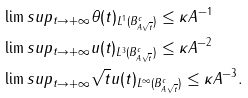<formula> <loc_0><loc_0><loc_500><loc_500>& \lim s u p _ { t \to + \infty } \| \theta ( t ) \| _ { L ^ { 1 } ( B _ { A \sqrt { t } } ^ { c } ) } \leq \kappa A ^ { - 1 } \\ & \lim s u p _ { t \to + \infty } \| u ( t ) \| _ { L ^ { 3 } ( B _ { A \sqrt { t } } ^ { c } ) } \leq \kappa A ^ { - 2 } \quad \\ & \lim s u p _ { t \to + \infty } \sqrt { t } \| u ( t ) \| _ { L ^ { \infty } ( B _ { A \sqrt { t } } ^ { c } ) } \leq \kappa A ^ { - 3 } .</formula> 